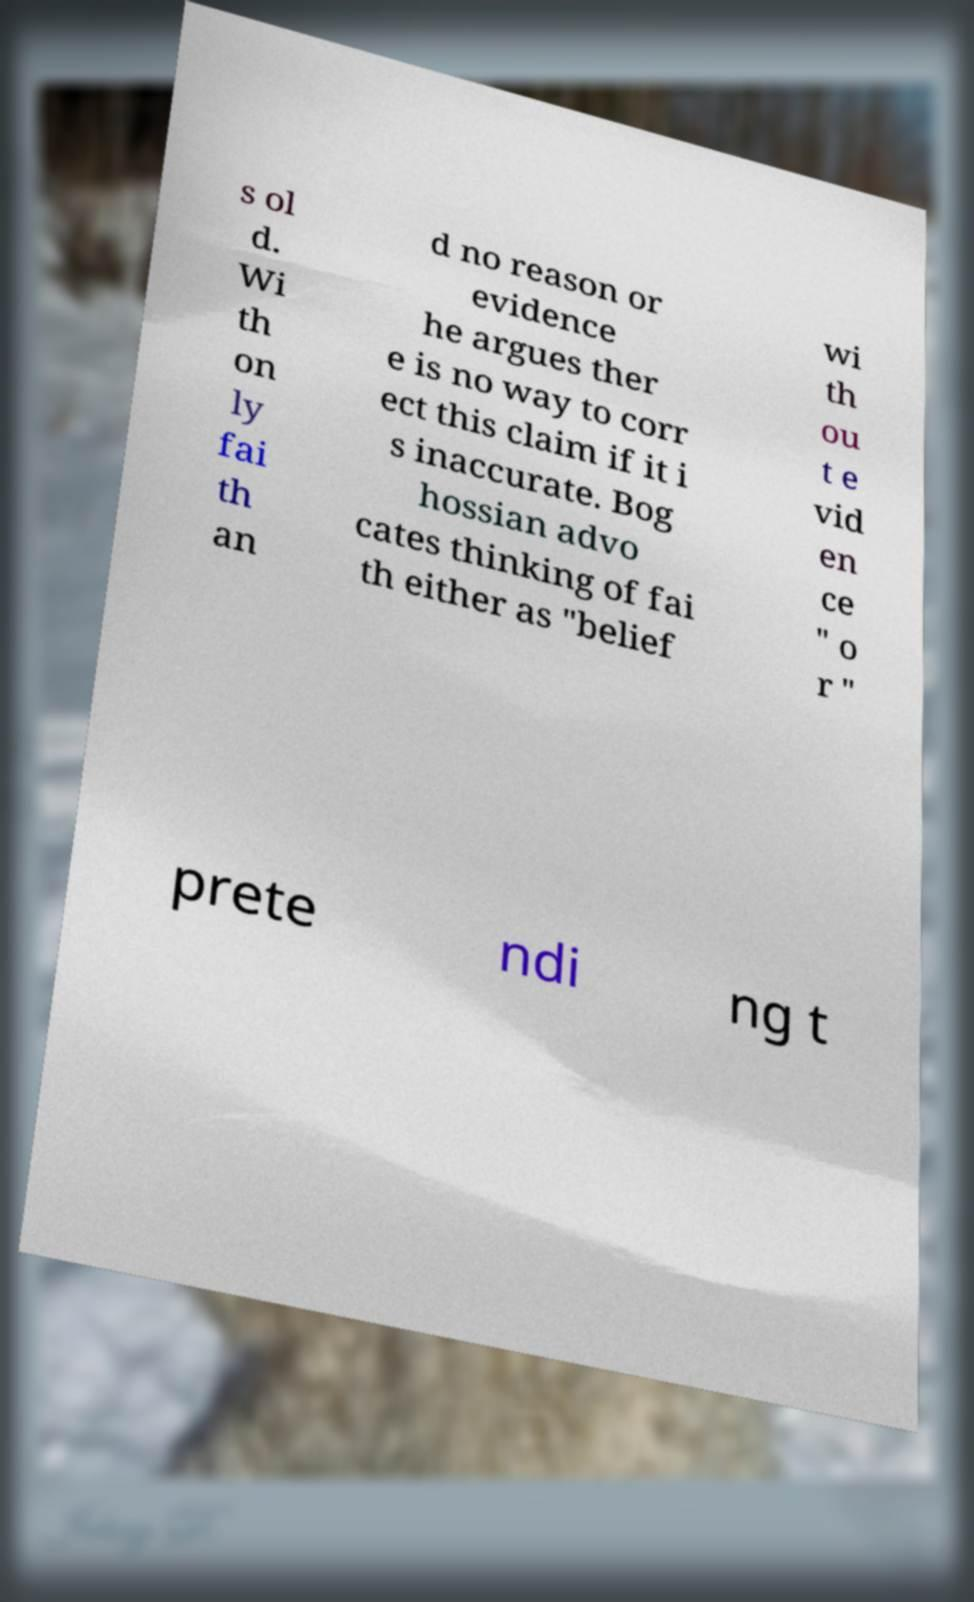Could you extract and type out the text from this image? s ol d. Wi th on ly fai th an d no reason or evidence he argues ther e is no way to corr ect this claim if it i s inaccurate. Bog hossian advo cates thinking of fai th either as "belief wi th ou t e vid en ce " o r " prete ndi ng t 